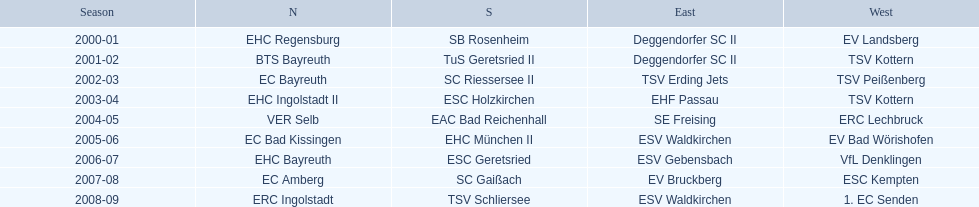Which teams played in the north? EHC Regensburg, BTS Bayreuth, EC Bayreuth, EHC Ingolstadt II, VER Selb, EC Bad Kissingen, EHC Bayreuth, EC Amberg, ERC Ingolstadt. Of these teams, which played during 2000-2001? EHC Regensburg. Parse the table in full. {'header': ['Season', 'N', 'S', 'East', 'West'], 'rows': [['2000-01', 'EHC Regensburg', 'SB Rosenheim', 'Deggendorfer SC II', 'EV Landsberg'], ['2001-02', 'BTS Bayreuth', 'TuS Geretsried II', 'Deggendorfer SC II', 'TSV Kottern'], ['2002-03', 'EC Bayreuth', 'SC Riessersee II', 'TSV Erding Jets', 'TSV Peißenberg'], ['2003-04', 'EHC Ingolstadt II', 'ESC Holzkirchen', 'EHF Passau', 'TSV Kottern'], ['2004-05', 'VER Selb', 'EAC Bad Reichenhall', 'SE Freising', 'ERC Lechbruck'], ['2005-06', 'EC Bad Kissingen', 'EHC München II', 'ESV Waldkirchen', 'EV Bad Wörishofen'], ['2006-07', 'EHC Bayreuth', 'ESC Geretsried', 'ESV Gebensbach', 'VfL Denklingen'], ['2007-08', 'EC Amberg', 'SC Gaißach', 'EV Bruckberg', 'ESC Kempten'], ['2008-09', 'ERC Ingolstadt', 'TSV Schliersee', 'ESV Waldkirchen', '1. EC Senden']]} 